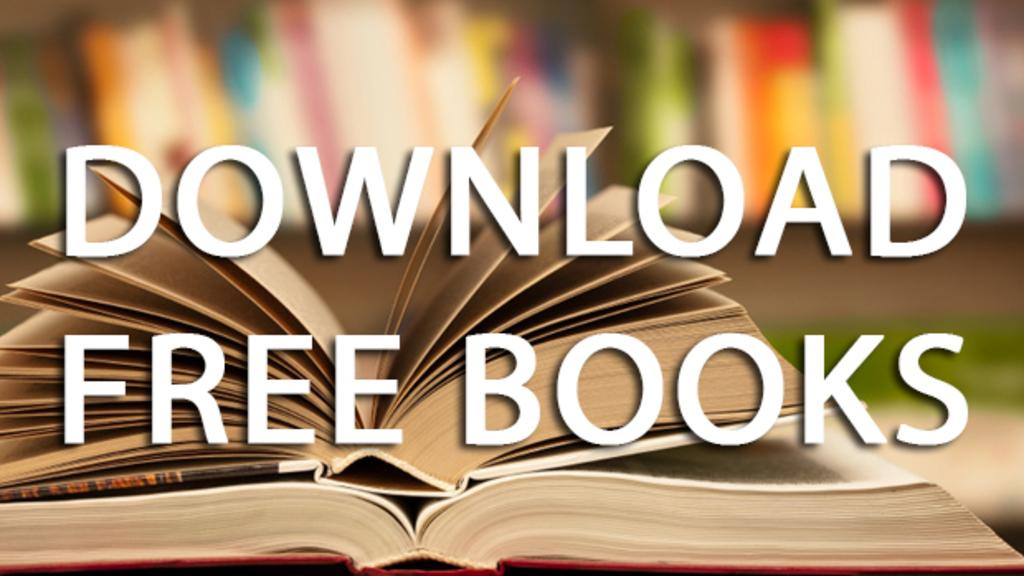<image>
Summarize the visual content of the image. An advertisement that says Download Free Books with an open and fanned book behind the text. 